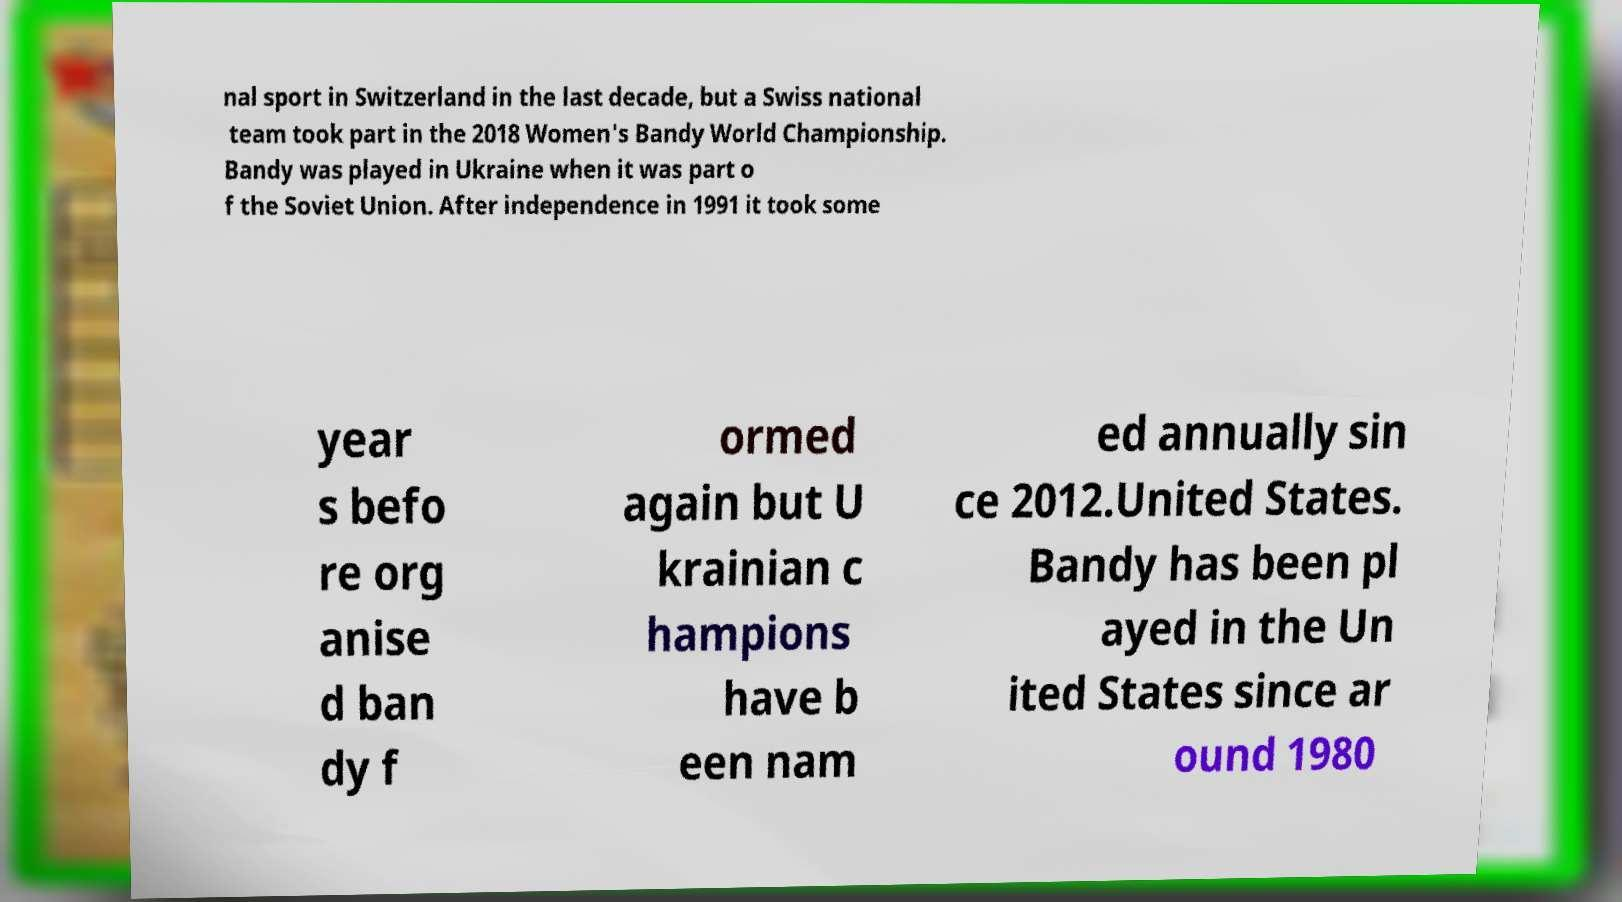Please identify and transcribe the text found in this image. nal sport in Switzerland in the last decade, but a Swiss national team took part in the 2018 Women's Bandy World Championship. Bandy was played in Ukraine when it was part o f the Soviet Union. After independence in 1991 it took some year s befo re org anise d ban dy f ormed again but U krainian c hampions have b een nam ed annually sin ce 2012.United States. Bandy has been pl ayed in the Un ited States since ar ound 1980 